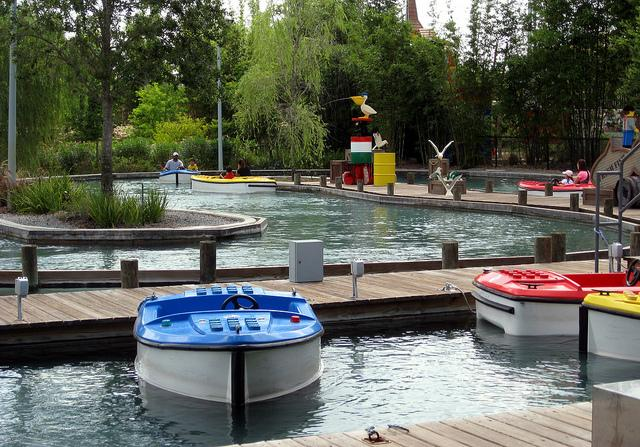What type of bird is on the red white and green barrel? pelican 